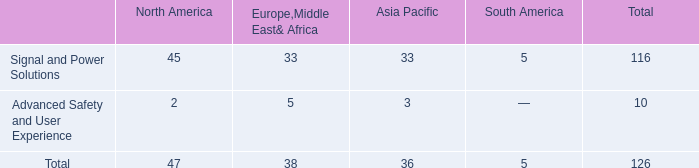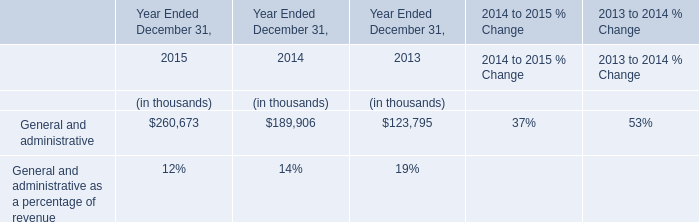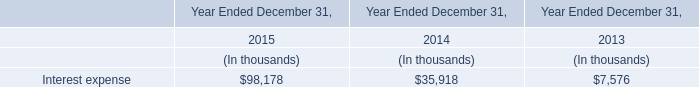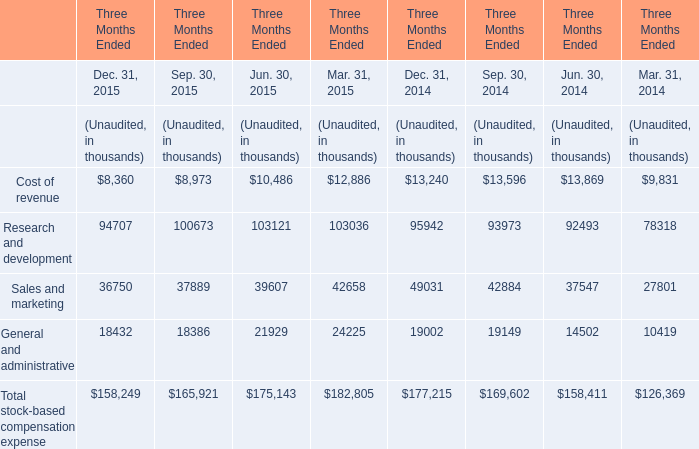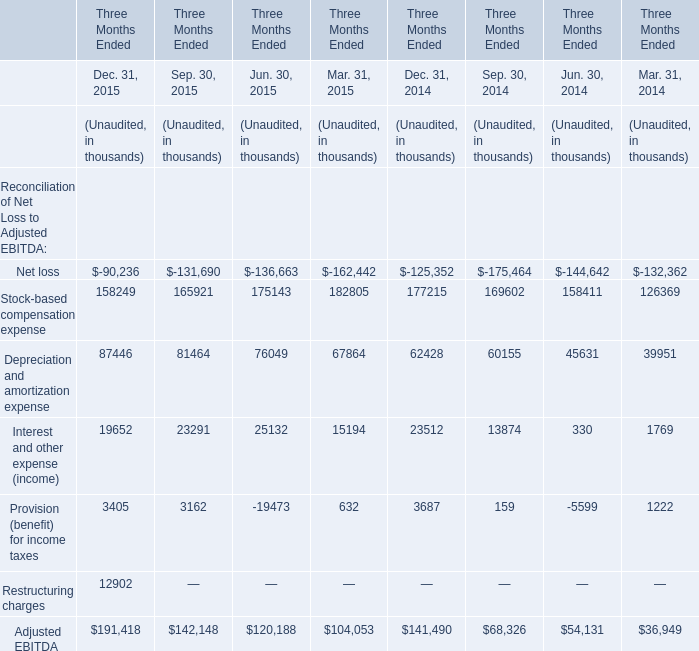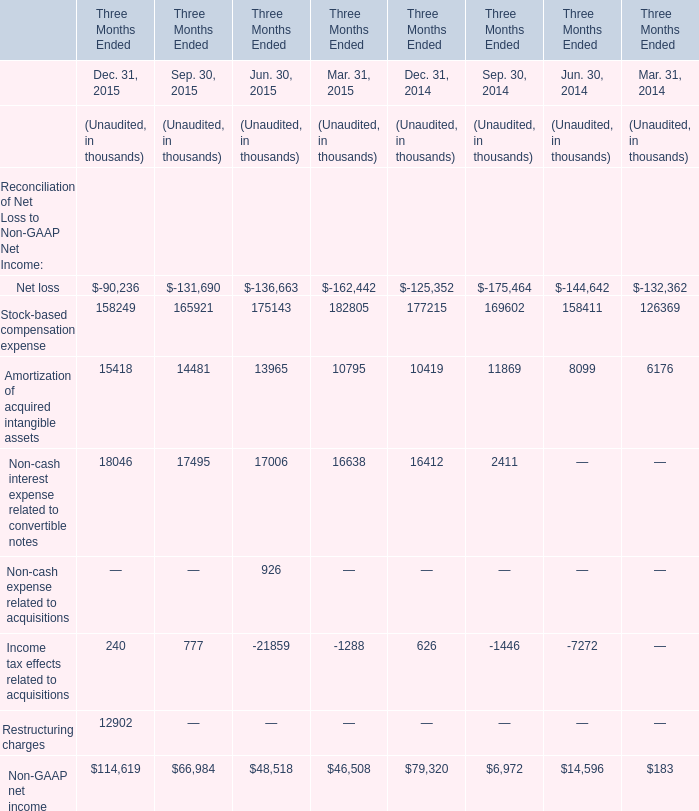The Amortization of acquired intangible assets of quarter what of 2015 Unaudited ranks first? 
Answer: 4. 